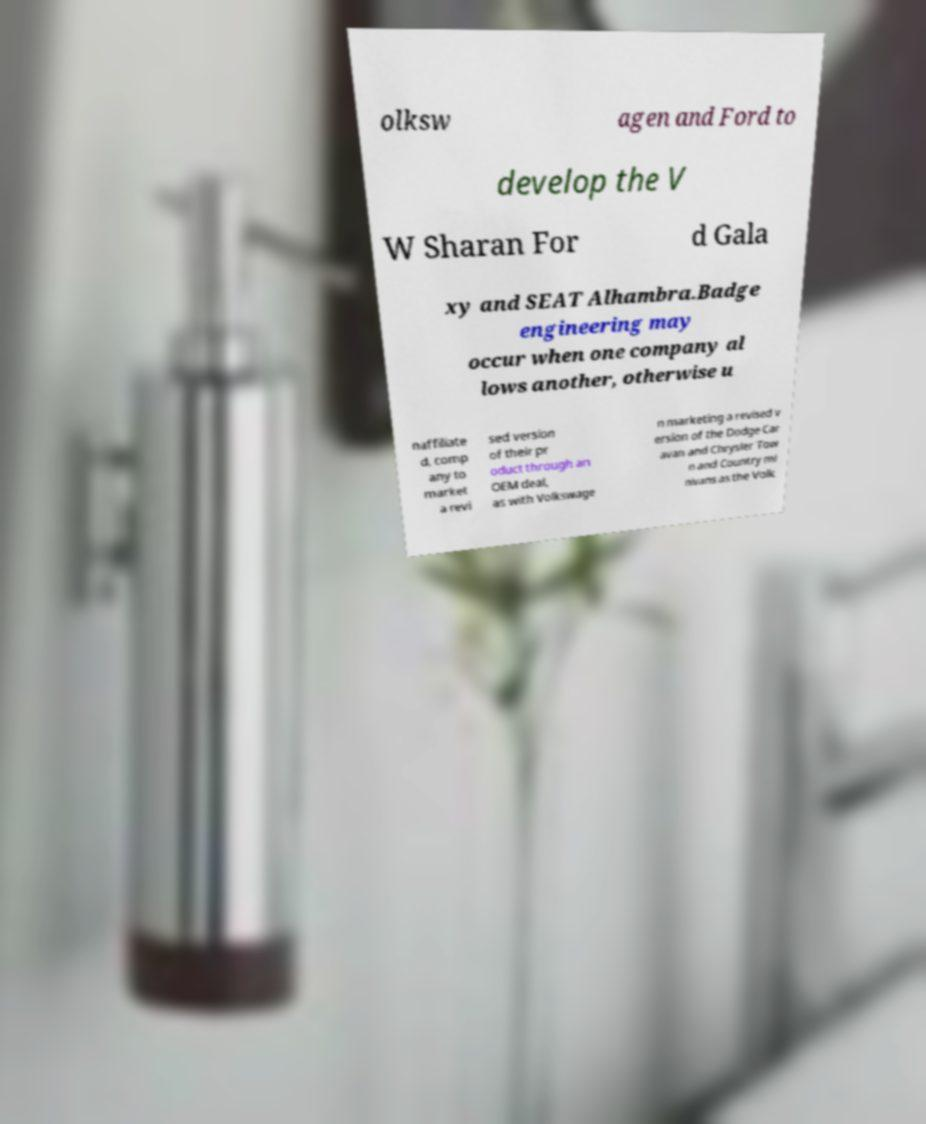What messages or text are displayed in this image? I need them in a readable, typed format. olksw agen and Ford to develop the V W Sharan For d Gala xy and SEAT Alhambra.Badge engineering may occur when one company al lows another, otherwise u naffiliate d, comp any to market a revi sed version of their pr oduct through an OEM deal, as with Volkswage n marketing a revised v ersion of the Dodge Car avan and Chrysler Tow n and Country mi nivans as the Volk 